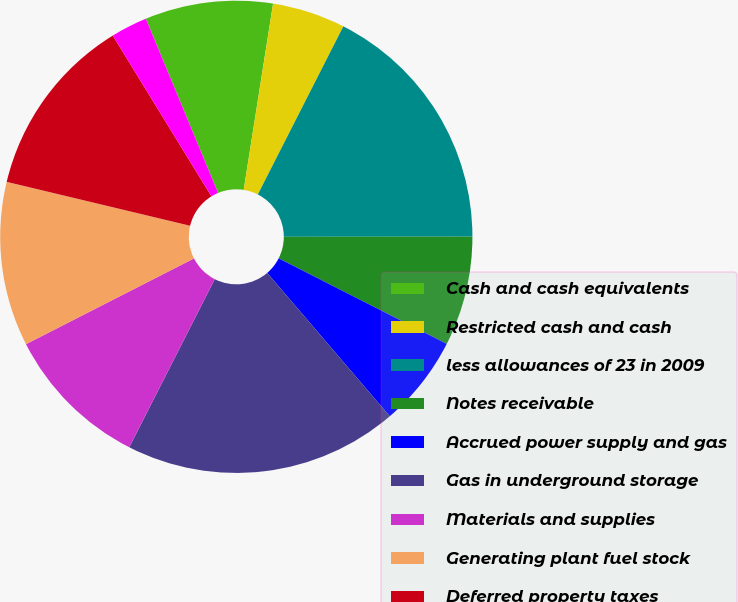<chart> <loc_0><loc_0><loc_500><loc_500><pie_chart><fcel>Cash and cash equivalents<fcel>Restricted cash and cash<fcel>less allowances of 23 in 2009<fcel>Notes receivable<fcel>Accrued power supply and gas<fcel>Gas in underground storage<fcel>Materials and supplies<fcel>Generating plant fuel stock<fcel>Deferred property taxes<fcel>Regulatory assets<nl><fcel>8.75%<fcel>5.0%<fcel>17.5%<fcel>7.5%<fcel>6.25%<fcel>18.75%<fcel>10.0%<fcel>11.25%<fcel>12.5%<fcel>2.5%<nl></chart> 